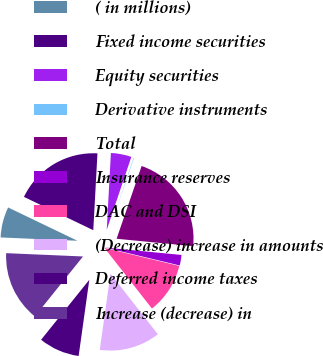Convert chart. <chart><loc_0><loc_0><loc_500><loc_500><pie_chart><fcel>( in millions)<fcel>Fixed income securities<fcel>Equity securities<fcel>Derivative instruments<fcel>Total<fcel>Insurance reserves<fcel>DAC and DSI<fcel>(Decrease) increase in amounts<fcel>Deferred income taxes<fcel>Increase (decrease) in<nl><fcel>6.44%<fcel>18.74%<fcel>4.32%<fcel>0.09%<fcel>21.27%<fcel>2.21%<fcel>10.68%<fcel>12.79%<fcel>8.56%<fcel>14.91%<nl></chart> 